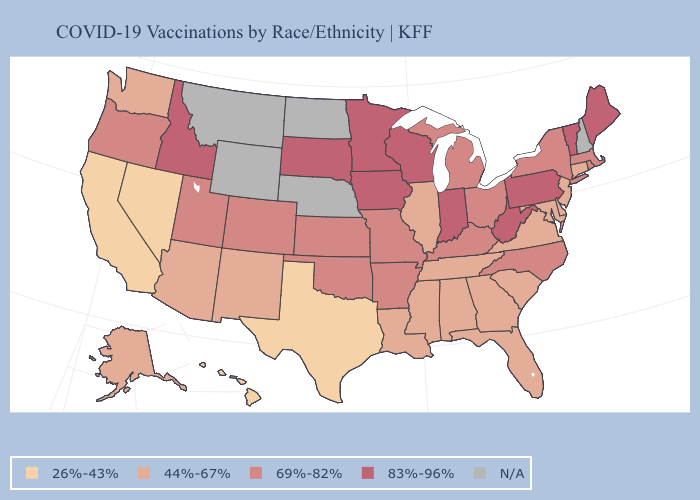Is the legend a continuous bar?
Give a very brief answer. No. Among the states that border Oklahoma , which have the lowest value?
Quick response, please. Texas. What is the highest value in the Northeast ?
Write a very short answer. 83%-96%. What is the value of New York?
Be succinct. 69%-82%. Name the states that have a value in the range 26%-43%?
Concise answer only. California, Hawaii, Nevada, Texas. What is the value of South Dakota?
Keep it brief. 83%-96%. Which states hav the highest value in the MidWest?
Answer briefly. Indiana, Iowa, Minnesota, South Dakota, Wisconsin. Among the states that border Nebraska , does Kansas have the lowest value?
Give a very brief answer. Yes. Does the first symbol in the legend represent the smallest category?
Quick response, please. Yes. What is the highest value in states that border New Mexico?
Keep it brief. 69%-82%. Among the states that border Indiana , does Kentucky have the highest value?
Be succinct. Yes. Does Louisiana have the lowest value in the South?
Write a very short answer. No. What is the value of Tennessee?
Give a very brief answer. 44%-67%. What is the value of Wisconsin?
Short answer required. 83%-96%. 